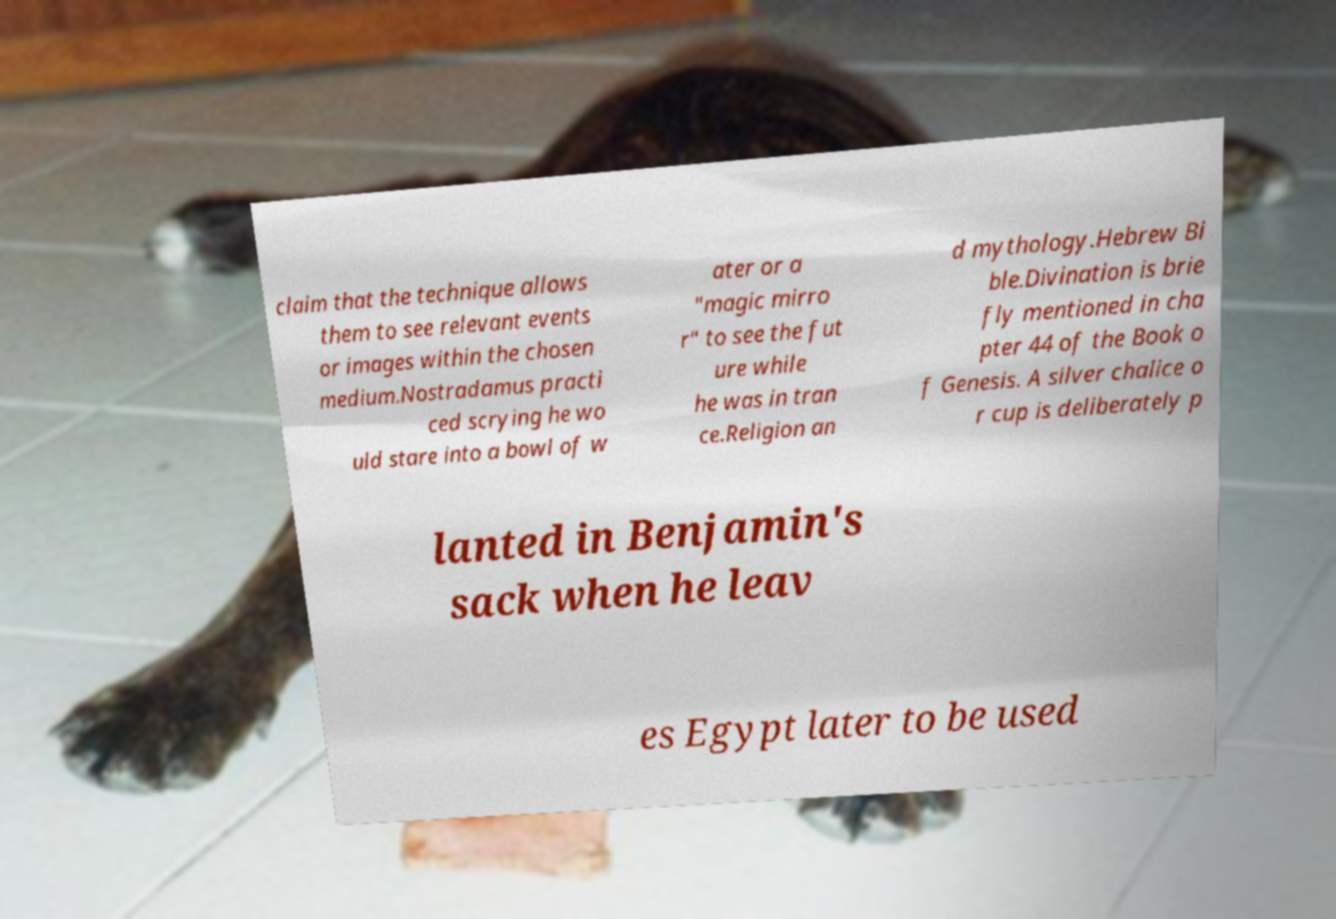Could you assist in decoding the text presented in this image and type it out clearly? claim that the technique allows them to see relevant events or images within the chosen medium.Nostradamus practi ced scrying he wo uld stare into a bowl of w ater or a "magic mirro r" to see the fut ure while he was in tran ce.Religion an d mythology.Hebrew Bi ble.Divination is brie fly mentioned in cha pter 44 of the Book o f Genesis. A silver chalice o r cup is deliberately p lanted in Benjamin's sack when he leav es Egypt later to be used 